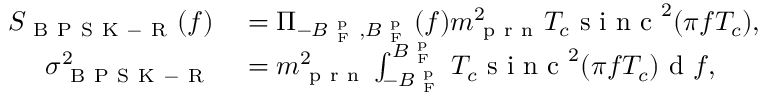Convert formula to latex. <formula><loc_0><loc_0><loc_500><loc_500>\begin{array} { r l } { S _ { B P S K - R } ( f ) } & = \Pi _ { - B _ { F } ^ { p } , B _ { F } ^ { p } } ( f ) m _ { p r n } ^ { 2 } T _ { c } s i n c ^ { 2 } ( \pi f T _ { c } ) , } \\ { \sigma _ { B P S K - R } ^ { 2 } } & = m _ { p r n } ^ { 2 } \int _ { - B _ { F } ^ { p } } ^ { B _ { F } ^ { p } } T _ { c } s i n c ^ { 2 } ( \pi f T _ { c } ) d f , } \end{array}</formula> 